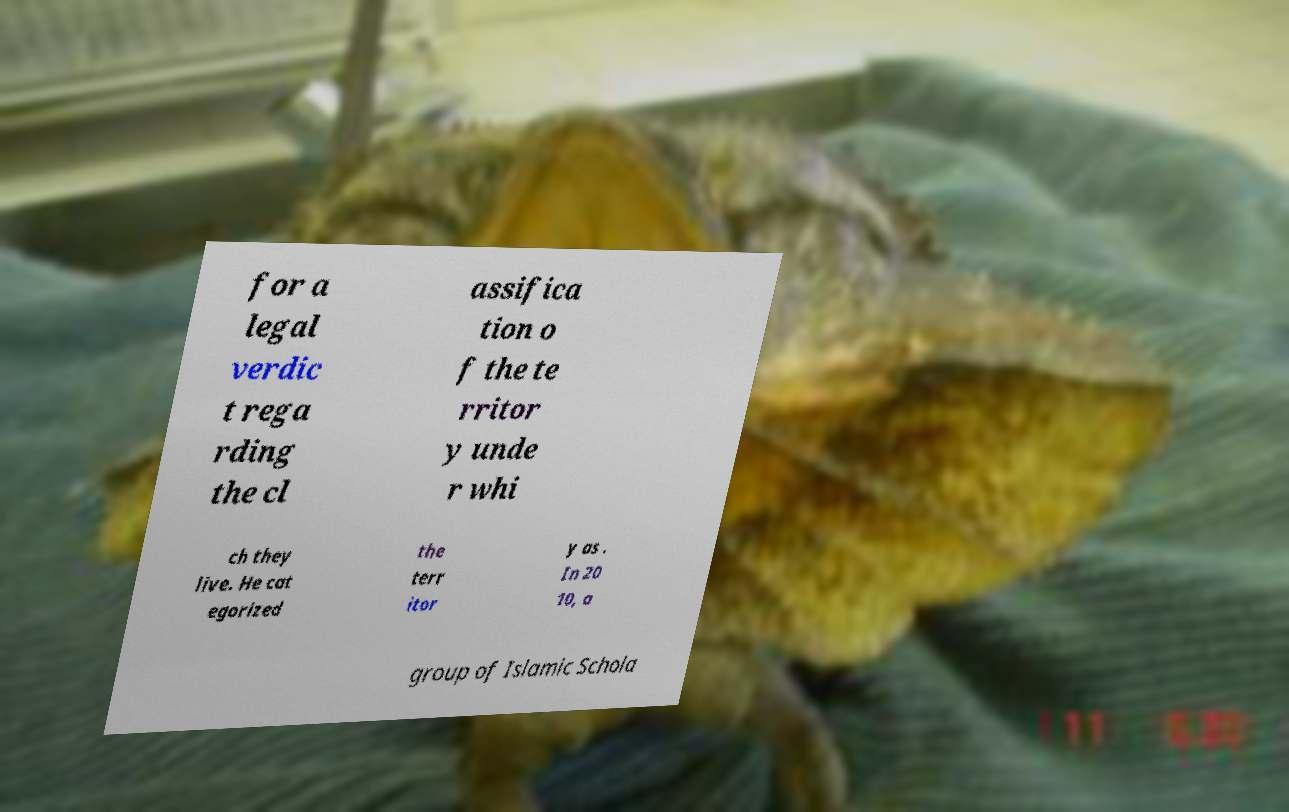There's text embedded in this image that I need extracted. Can you transcribe it verbatim? for a legal verdic t rega rding the cl assifica tion o f the te rritor y unde r whi ch they live. He cat egorized the terr itor y as . In 20 10, a group of Islamic Schola 